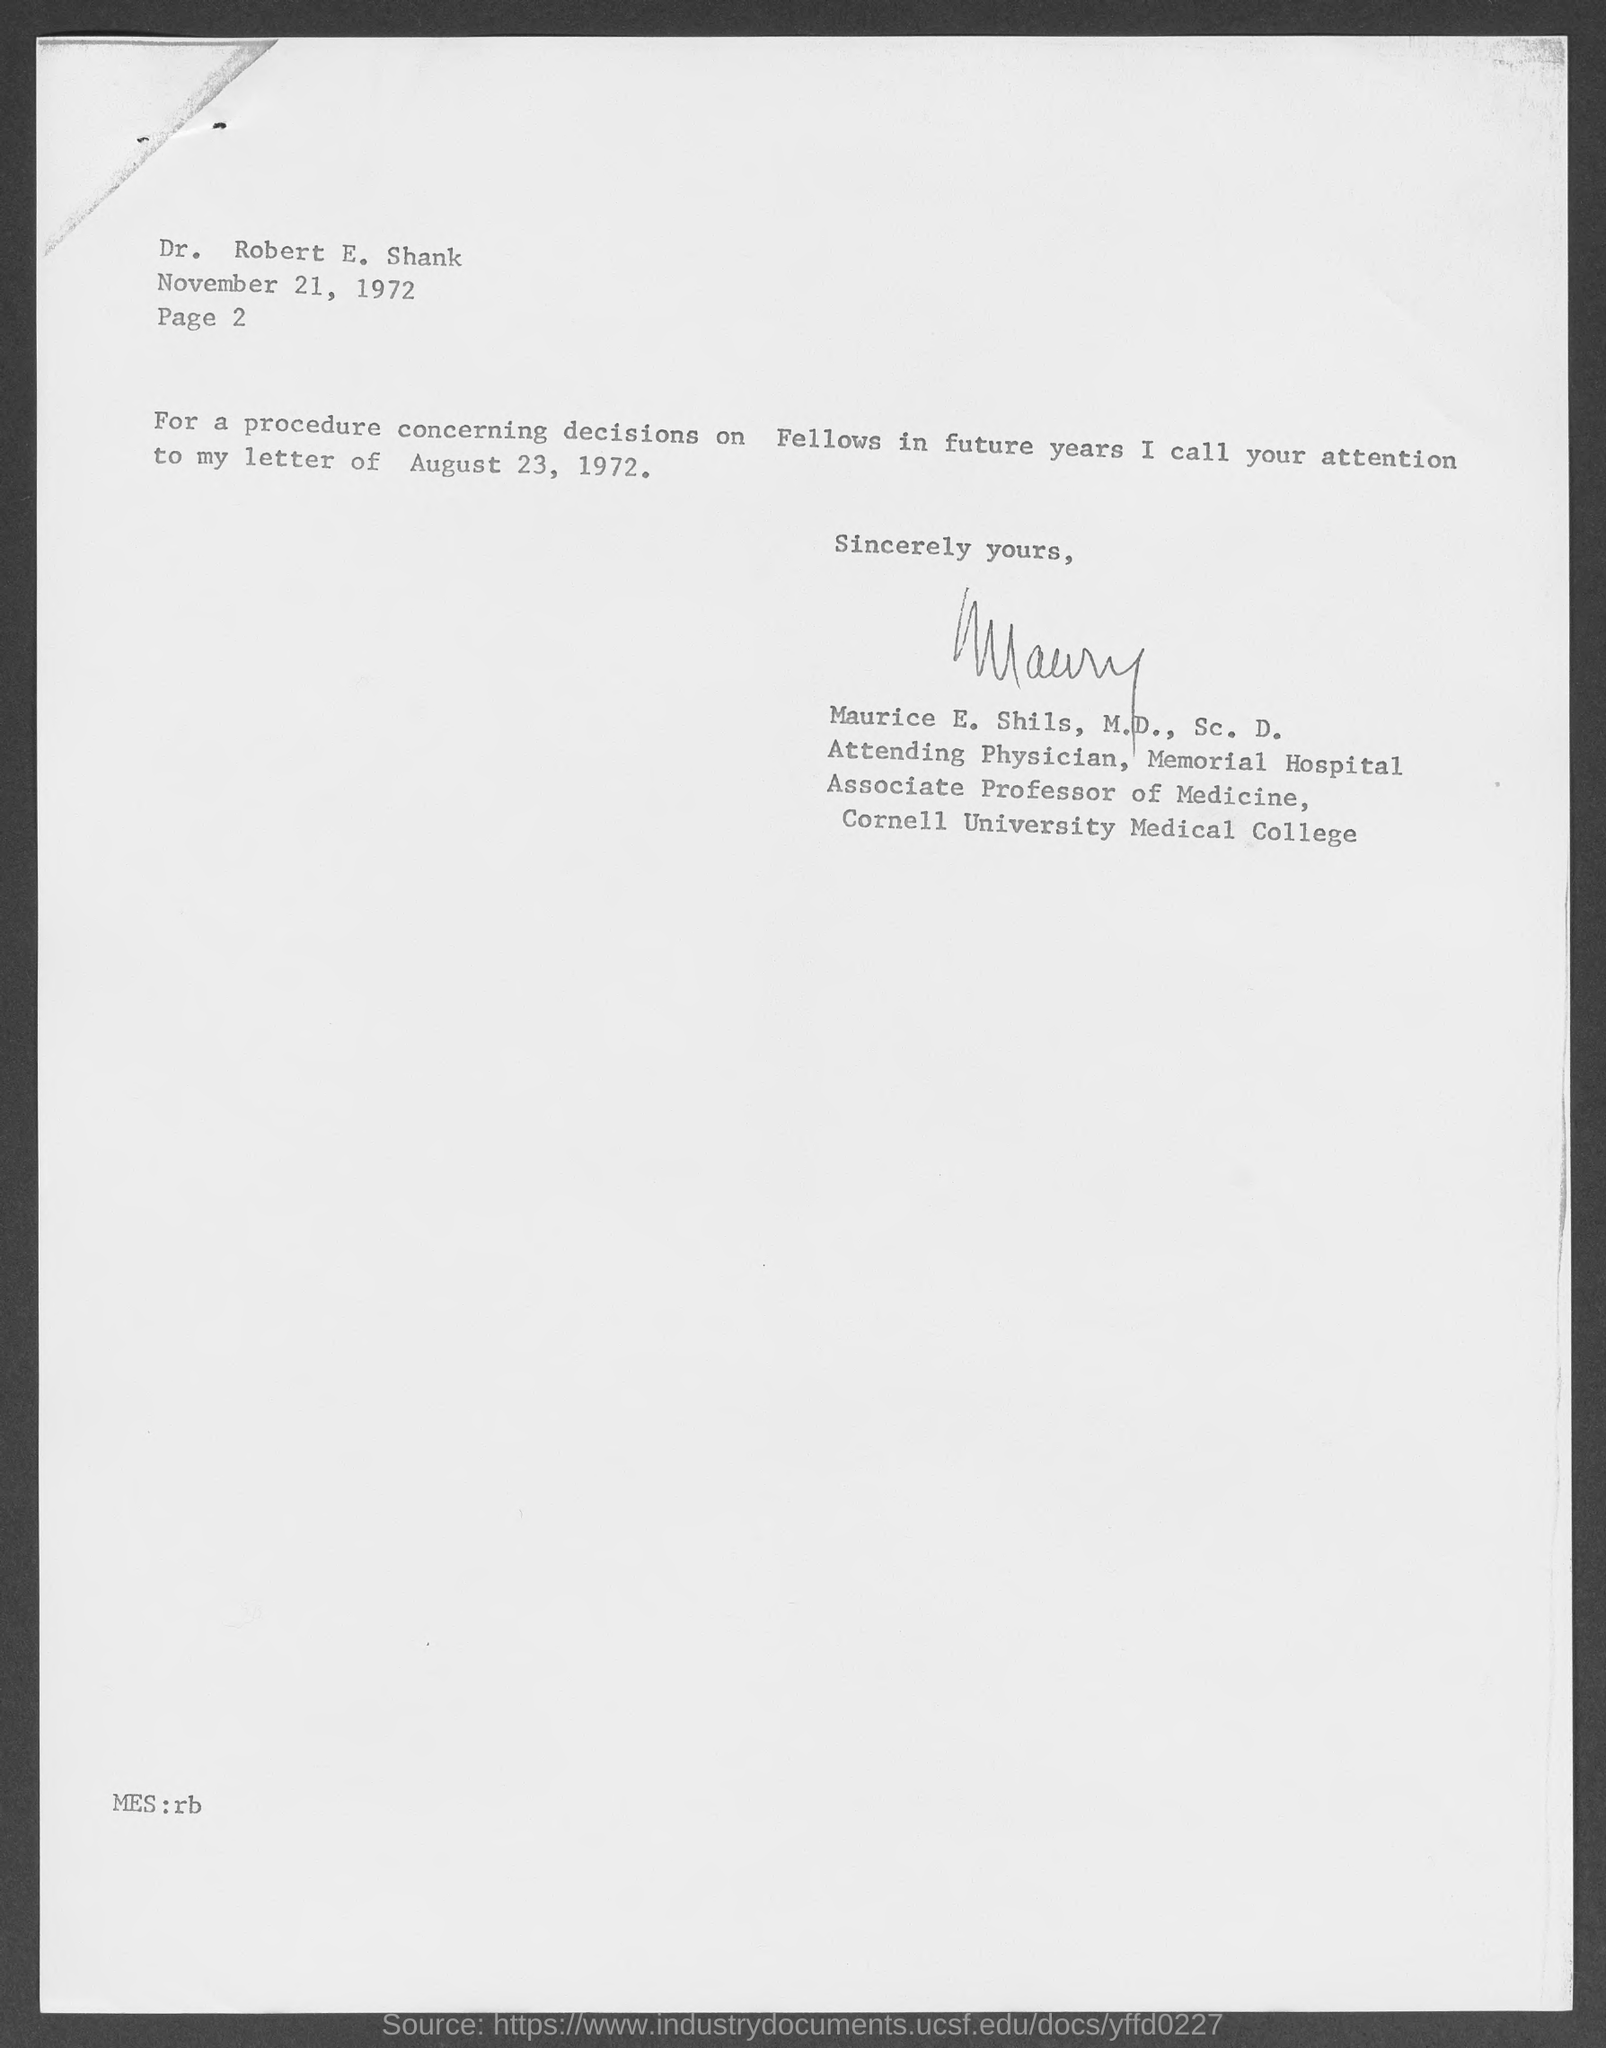Who is the letter address to?
Your answer should be very brief. Robert E. Shank. In which page number is mentioned?
Offer a very short reply. 2. 